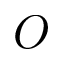Convert formula to latex. <formula><loc_0><loc_0><loc_500><loc_500>O</formula> 